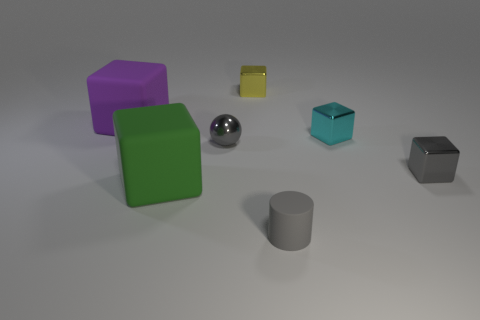Add 2 large green matte blocks. How many objects exist? 9 Subtract 1 balls. How many balls are left? 0 Subtract all yellow shiny cubes. How many cubes are left? 4 Subtract 1 gray cylinders. How many objects are left? 6 Subtract all spheres. How many objects are left? 6 Subtract all cyan cylinders. Subtract all purple spheres. How many cylinders are left? 1 Subtract all brown cylinders. How many yellow cubes are left? 1 Subtract all tiny matte things. Subtract all green things. How many objects are left? 5 Add 6 big purple rubber blocks. How many big purple rubber blocks are left? 7 Add 7 big objects. How many big objects exist? 9 